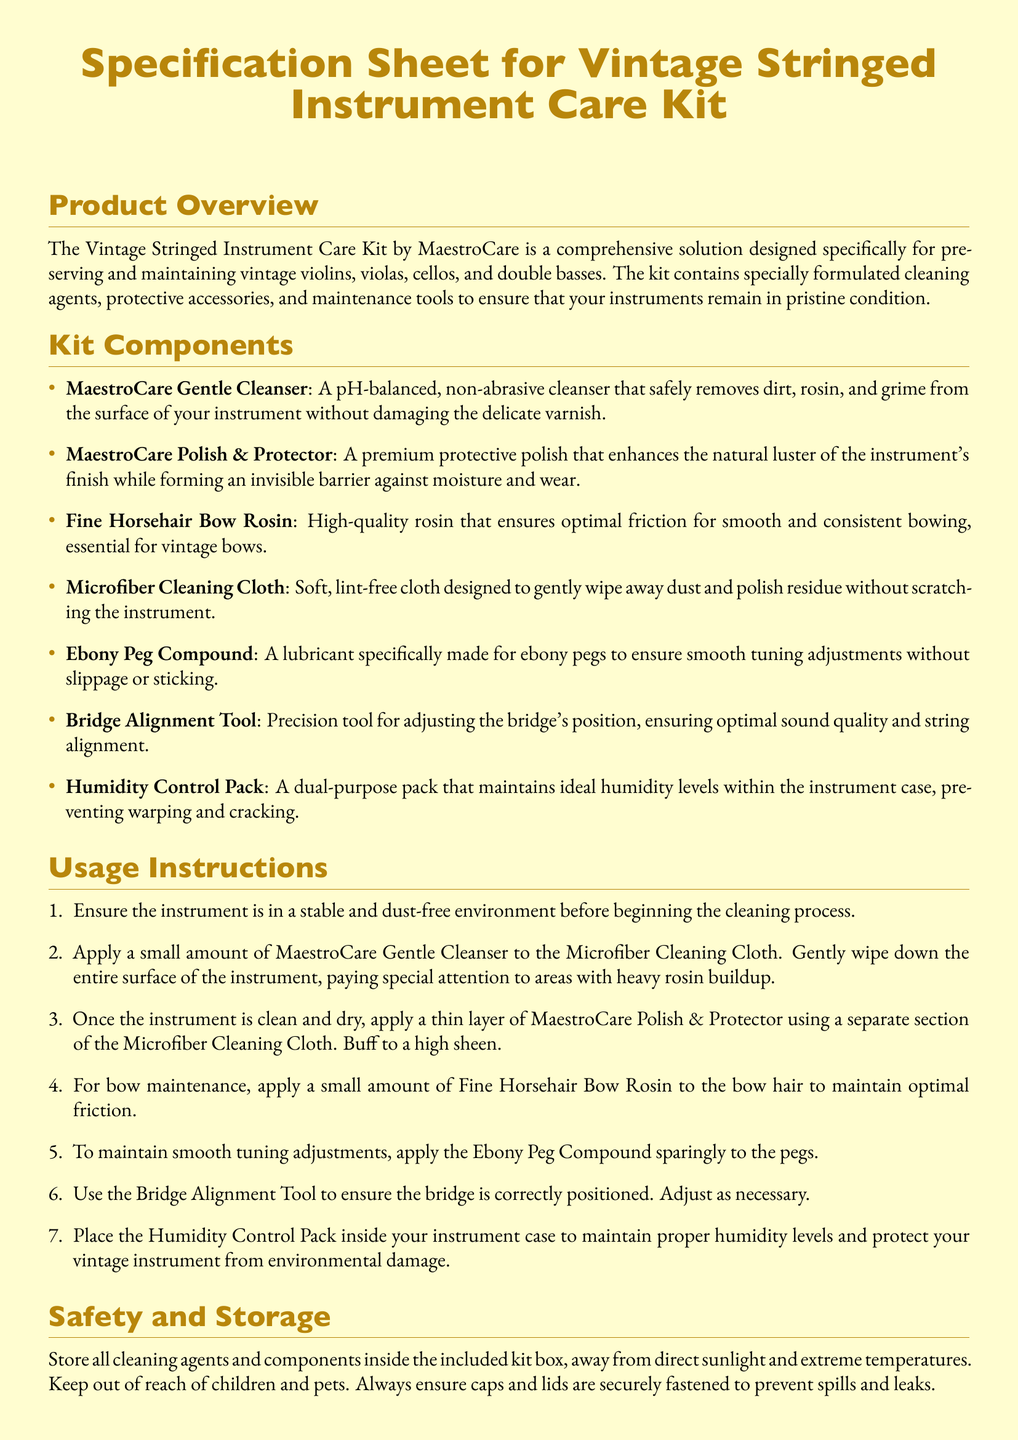What is the brand name of the care kit? The brand name mentioned in the document is the manufacturer of the care kit for vintage stringed instruments.
Answer: MaestroCare How many components are included in the kit? The kit components section lists a total of seven items.
Answer: Seven What is the purpose of the Ebony Peg Compound? The explanation in the kit components details that the compound ensures smooth tuning adjustments.
Answer: Smooth tuning adjustments What should be applied to the bow hair? The usage instructions specify the maintenance process for the bow hair in the context of optimal friction.
Answer: Fine Horsehair Bow Rosin What is the warranty period for the product? The support and warranty section states the warranty duration against manufacturing defects.
Answer: 1 year What type of cloth is included in the kit? The kit components section describes the properties and purpose of the microfiber cleaning cloth.
Answer: Microfiber Cleaning Cloth Why is the Humidity Control Pack included? The usage instructions clarify the purpose of this pack in relation to environmental protection.
Answer: Preventing warping and cracking What should be done to the cleaning agents after use? The safety and storage section offers guidance on how to store the contents of the care kit.
Answer: Store in the included kit box Where can customers get support for the product? The support and warranty section provides contact details for customer service inquiries.
Answer: support@maestrocare.com 